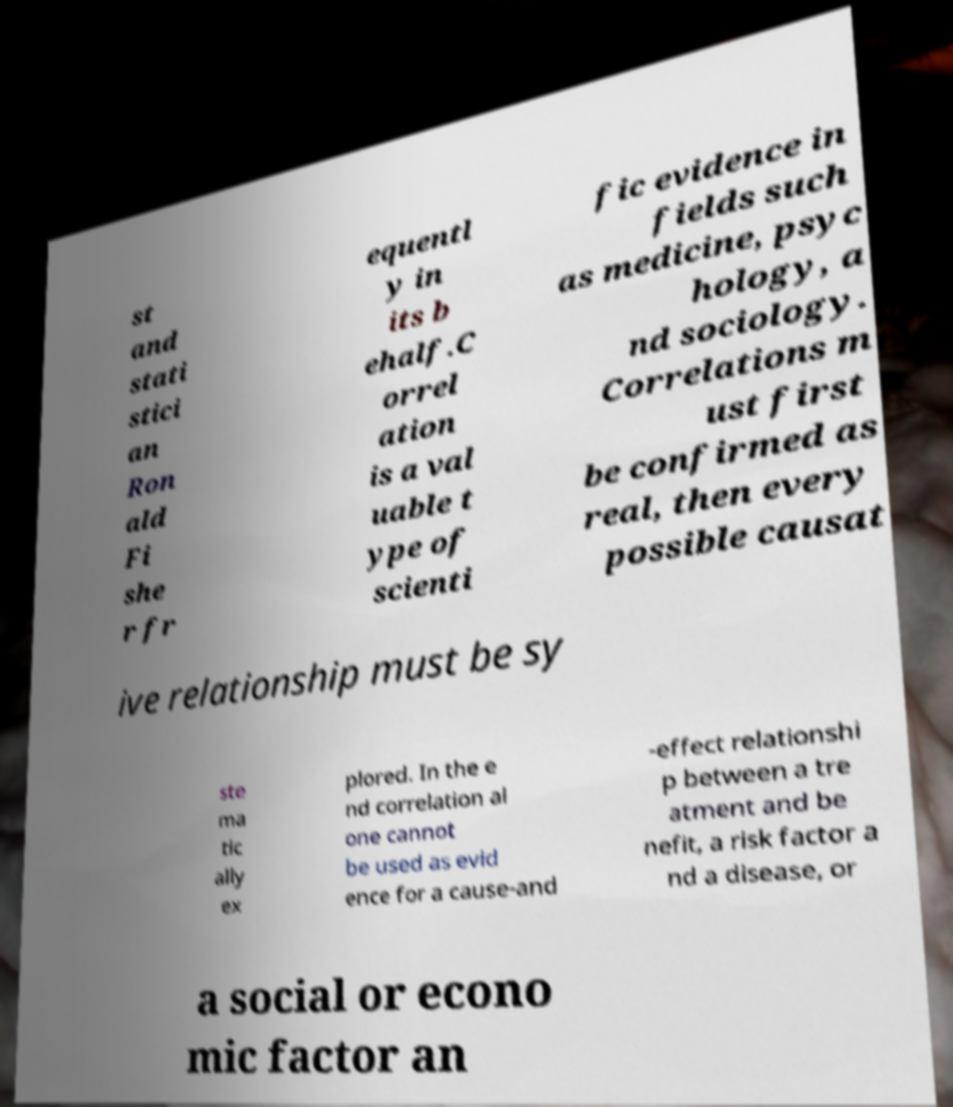Can you accurately transcribe the text from the provided image for me? st and stati stici an Ron ald Fi she r fr equentl y in its b ehalf.C orrel ation is a val uable t ype of scienti fic evidence in fields such as medicine, psyc hology, a nd sociology. Correlations m ust first be confirmed as real, then every possible causat ive relationship must be sy ste ma tic ally ex plored. In the e nd correlation al one cannot be used as evid ence for a cause-and -effect relationshi p between a tre atment and be nefit, a risk factor a nd a disease, or a social or econo mic factor an 